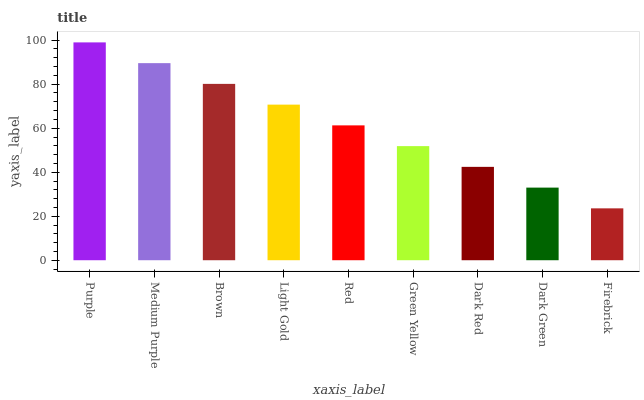Is Firebrick the minimum?
Answer yes or no. Yes. Is Purple the maximum?
Answer yes or no. Yes. Is Medium Purple the minimum?
Answer yes or no. No. Is Medium Purple the maximum?
Answer yes or no. No. Is Purple greater than Medium Purple?
Answer yes or no. Yes. Is Medium Purple less than Purple?
Answer yes or no. Yes. Is Medium Purple greater than Purple?
Answer yes or no. No. Is Purple less than Medium Purple?
Answer yes or no. No. Is Red the high median?
Answer yes or no. Yes. Is Red the low median?
Answer yes or no. Yes. Is Dark Green the high median?
Answer yes or no. No. Is Dark Green the low median?
Answer yes or no. No. 